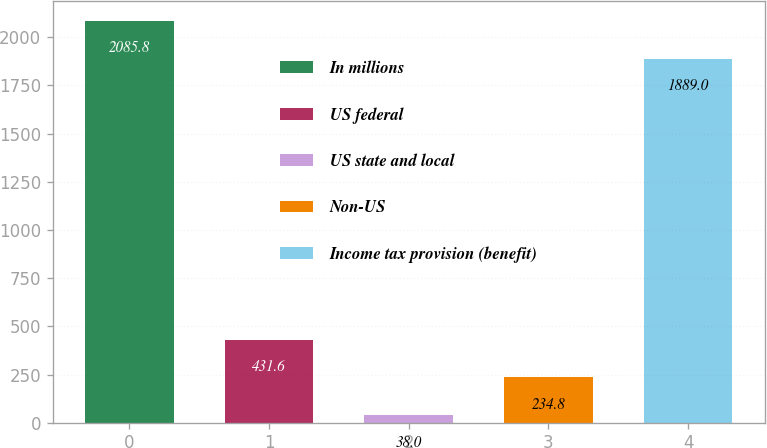Convert chart to OTSL. <chart><loc_0><loc_0><loc_500><loc_500><bar_chart><fcel>In millions<fcel>US federal<fcel>US state and local<fcel>Non-US<fcel>Income tax provision (benefit)<nl><fcel>2085.8<fcel>431.6<fcel>38<fcel>234.8<fcel>1889<nl></chart> 